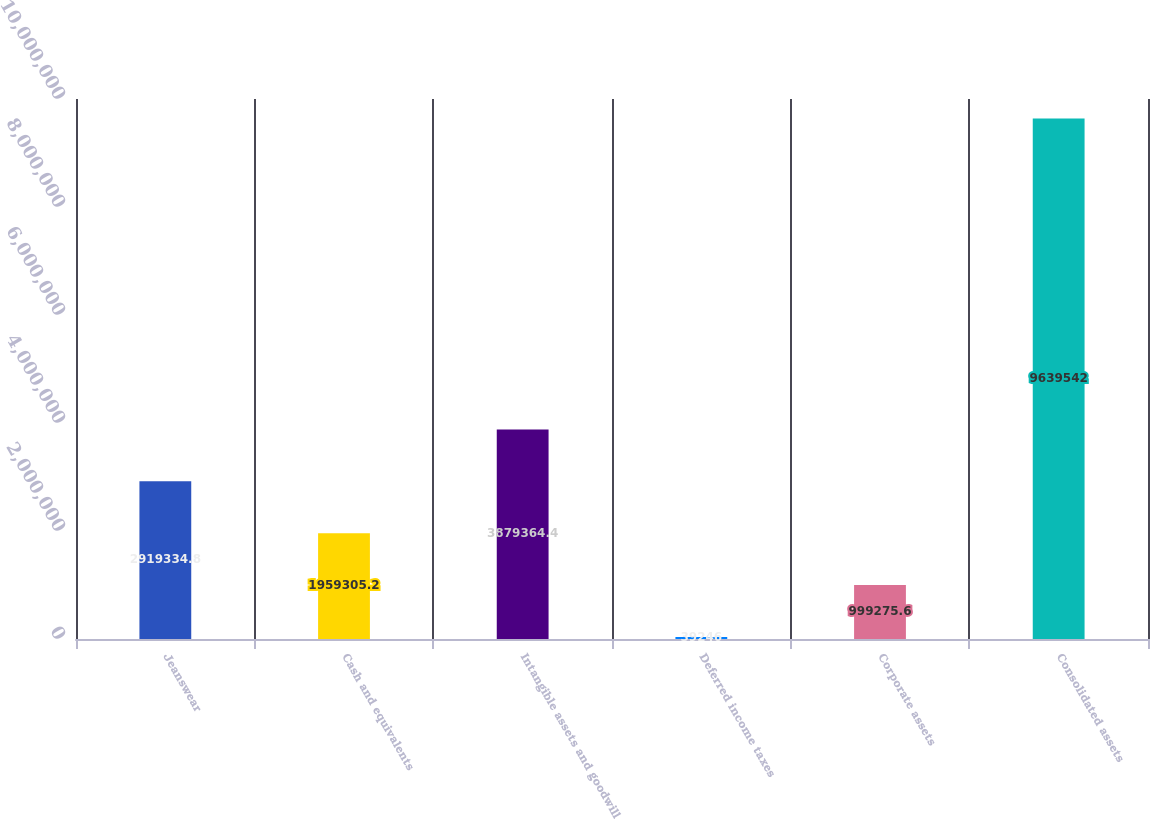Convert chart. <chart><loc_0><loc_0><loc_500><loc_500><bar_chart><fcel>Jeanswear<fcel>Cash and equivalents<fcel>Intangible assets and goodwill<fcel>Deferred income taxes<fcel>Corporate assets<fcel>Consolidated assets<nl><fcel>2.91933e+06<fcel>1.95931e+06<fcel>3.87936e+06<fcel>39246<fcel>999276<fcel>9.63954e+06<nl></chart> 